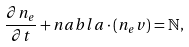Convert formula to latex. <formula><loc_0><loc_0><loc_500><loc_500>\frac { \partial n _ { e } } { \partial t } + { n a b l a } \cdot \left ( n _ { e } { v } \right ) = { \mathbb { N } } ,</formula> 